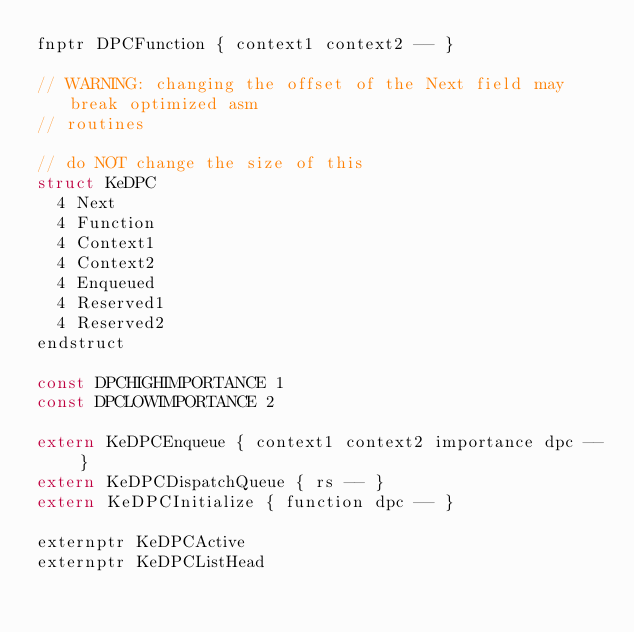Convert code to text. <code><loc_0><loc_0><loc_500><loc_500><_C_>fnptr DPCFunction { context1 context2 -- }

// WARNING: changing the offset of the Next field may break optimized asm
// routines

// do NOT change the size of this
struct KeDPC
	4 Next
	4 Function
	4 Context1
	4 Context2
	4 Enqueued
	4 Reserved1
	4 Reserved2
endstruct

const DPCHIGHIMPORTANCE 1
const DPCLOWIMPORTANCE 2

extern KeDPCEnqueue { context1 context2 importance dpc -- }
extern KeDPCDispatchQueue { rs -- }
extern KeDPCInitialize { function dpc -- }

externptr KeDPCActive
externptr KeDPCListHead</code> 